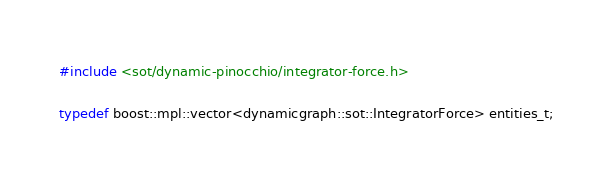Convert code to text. <code><loc_0><loc_0><loc_500><loc_500><_C++_>#include <sot/dynamic-pinocchio/integrator-force.h>

typedef boost::mpl::vector<dynamicgraph::sot::IntegratorForce> entities_t;
</code> 